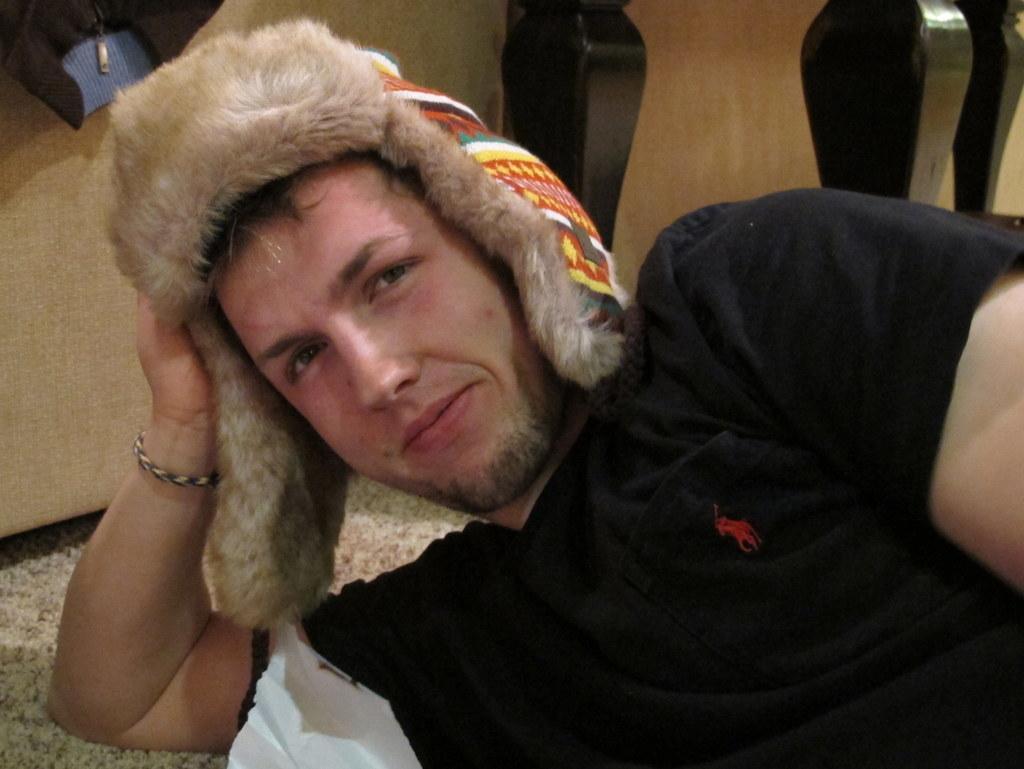Could you give a brief overview of what you see in this image? In the center of the image, we can see a man wearing cap and lying. In the background, there is a cot. 